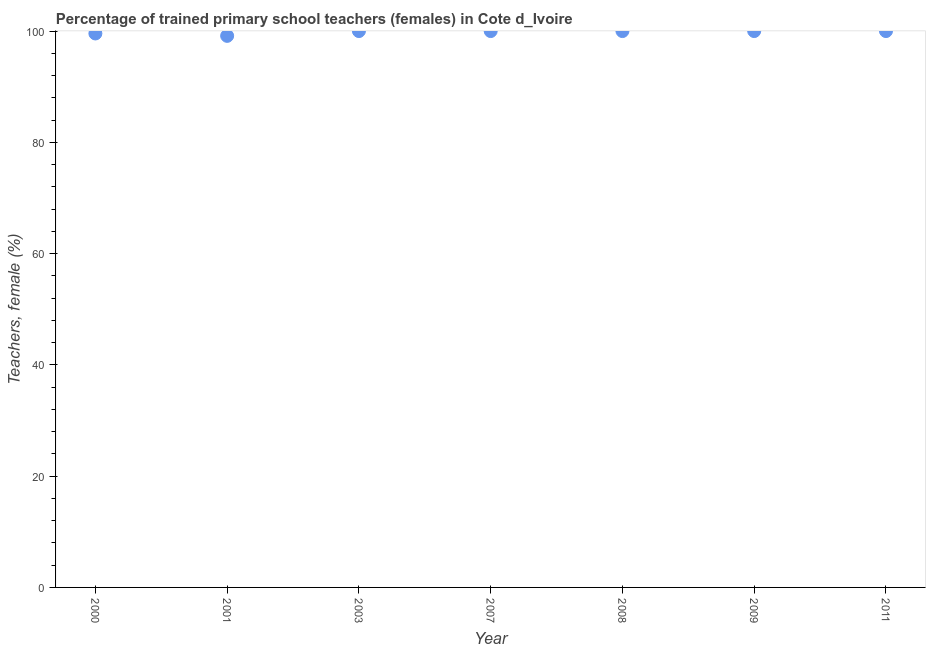Across all years, what is the maximum percentage of trained female teachers?
Keep it short and to the point. 100. Across all years, what is the minimum percentage of trained female teachers?
Provide a succinct answer. 99.14. In which year was the percentage of trained female teachers maximum?
Provide a succinct answer. 2003. What is the sum of the percentage of trained female teachers?
Your answer should be compact. 698.7. What is the difference between the percentage of trained female teachers in 2001 and 2009?
Make the answer very short. -0.86. What is the average percentage of trained female teachers per year?
Provide a short and direct response. 99.81. What is the median percentage of trained female teachers?
Your answer should be compact. 100. Do a majority of the years between 2000 and 2007 (inclusive) have percentage of trained female teachers greater than 52 %?
Make the answer very short. Yes. What is the ratio of the percentage of trained female teachers in 2000 to that in 2008?
Offer a terse response. 1. Is the difference between the percentage of trained female teachers in 2007 and 2011 greater than the difference between any two years?
Give a very brief answer. No. Is the sum of the percentage of trained female teachers in 2000 and 2011 greater than the maximum percentage of trained female teachers across all years?
Keep it short and to the point. Yes. What is the difference between the highest and the lowest percentage of trained female teachers?
Ensure brevity in your answer.  0.86. In how many years, is the percentage of trained female teachers greater than the average percentage of trained female teachers taken over all years?
Make the answer very short. 5. How many dotlines are there?
Your answer should be very brief. 1. How many years are there in the graph?
Make the answer very short. 7. What is the difference between two consecutive major ticks on the Y-axis?
Keep it short and to the point. 20. Are the values on the major ticks of Y-axis written in scientific E-notation?
Make the answer very short. No. Does the graph contain any zero values?
Ensure brevity in your answer.  No. What is the title of the graph?
Make the answer very short. Percentage of trained primary school teachers (females) in Cote d_Ivoire. What is the label or title of the X-axis?
Offer a very short reply. Year. What is the label or title of the Y-axis?
Provide a succinct answer. Teachers, female (%). What is the Teachers, female (%) in 2000?
Your response must be concise. 99.57. What is the Teachers, female (%) in 2001?
Make the answer very short. 99.14. What is the Teachers, female (%) in 2007?
Keep it short and to the point. 100. What is the Teachers, female (%) in 2009?
Make the answer very short. 100. What is the Teachers, female (%) in 2011?
Your answer should be very brief. 100. What is the difference between the Teachers, female (%) in 2000 and 2001?
Provide a short and direct response. 0.43. What is the difference between the Teachers, female (%) in 2000 and 2003?
Your response must be concise. -0.43. What is the difference between the Teachers, female (%) in 2000 and 2007?
Ensure brevity in your answer.  -0.43. What is the difference between the Teachers, female (%) in 2000 and 2008?
Provide a short and direct response. -0.43. What is the difference between the Teachers, female (%) in 2000 and 2009?
Ensure brevity in your answer.  -0.43. What is the difference between the Teachers, female (%) in 2000 and 2011?
Offer a very short reply. -0.43. What is the difference between the Teachers, female (%) in 2001 and 2003?
Give a very brief answer. -0.86. What is the difference between the Teachers, female (%) in 2001 and 2007?
Provide a short and direct response. -0.86. What is the difference between the Teachers, female (%) in 2001 and 2008?
Offer a very short reply. -0.86. What is the difference between the Teachers, female (%) in 2001 and 2009?
Offer a terse response. -0.86. What is the difference between the Teachers, female (%) in 2001 and 2011?
Offer a terse response. -0.86. What is the difference between the Teachers, female (%) in 2003 and 2007?
Provide a succinct answer. 0. What is the difference between the Teachers, female (%) in 2003 and 2008?
Your answer should be compact. 0. What is the difference between the Teachers, female (%) in 2003 and 2009?
Keep it short and to the point. 0. What is the difference between the Teachers, female (%) in 2003 and 2011?
Keep it short and to the point. 0. What is the difference between the Teachers, female (%) in 2007 and 2011?
Offer a terse response. 0. What is the difference between the Teachers, female (%) in 2008 and 2009?
Provide a short and direct response. 0. What is the difference between the Teachers, female (%) in 2008 and 2011?
Offer a very short reply. 0. What is the ratio of the Teachers, female (%) in 2000 to that in 2001?
Provide a short and direct response. 1. What is the ratio of the Teachers, female (%) in 2000 to that in 2008?
Provide a succinct answer. 1. What is the ratio of the Teachers, female (%) in 2000 to that in 2009?
Your answer should be compact. 1. What is the ratio of the Teachers, female (%) in 2000 to that in 2011?
Ensure brevity in your answer.  1. What is the ratio of the Teachers, female (%) in 2001 to that in 2007?
Ensure brevity in your answer.  0.99. What is the ratio of the Teachers, female (%) in 2001 to that in 2011?
Ensure brevity in your answer.  0.99. What is the ratio of the Teachers, female (%) in 2003 to that in 2007?
Your answer should be very brief. 1. What is the ratio of the Teachers, female (%) in 2003 to that in 2008?
Your answer should be very brief. 1. What is the ratio of the Teachers, female (%) in 2007 to that in 2008?
Provide a short and direct response. 1. What is the ratio of the Teachers, female (%) in 2007 to that in 2009?
Offer a very short reply. 1. What is the ratio of the Teachers, female (%) in 2008 to that in 2011?
Provide a succinct answer. 1. What is the ratio of the Teachers, female (%) in 2009 to that in 2011?
Provide a short and direct response. 1. 